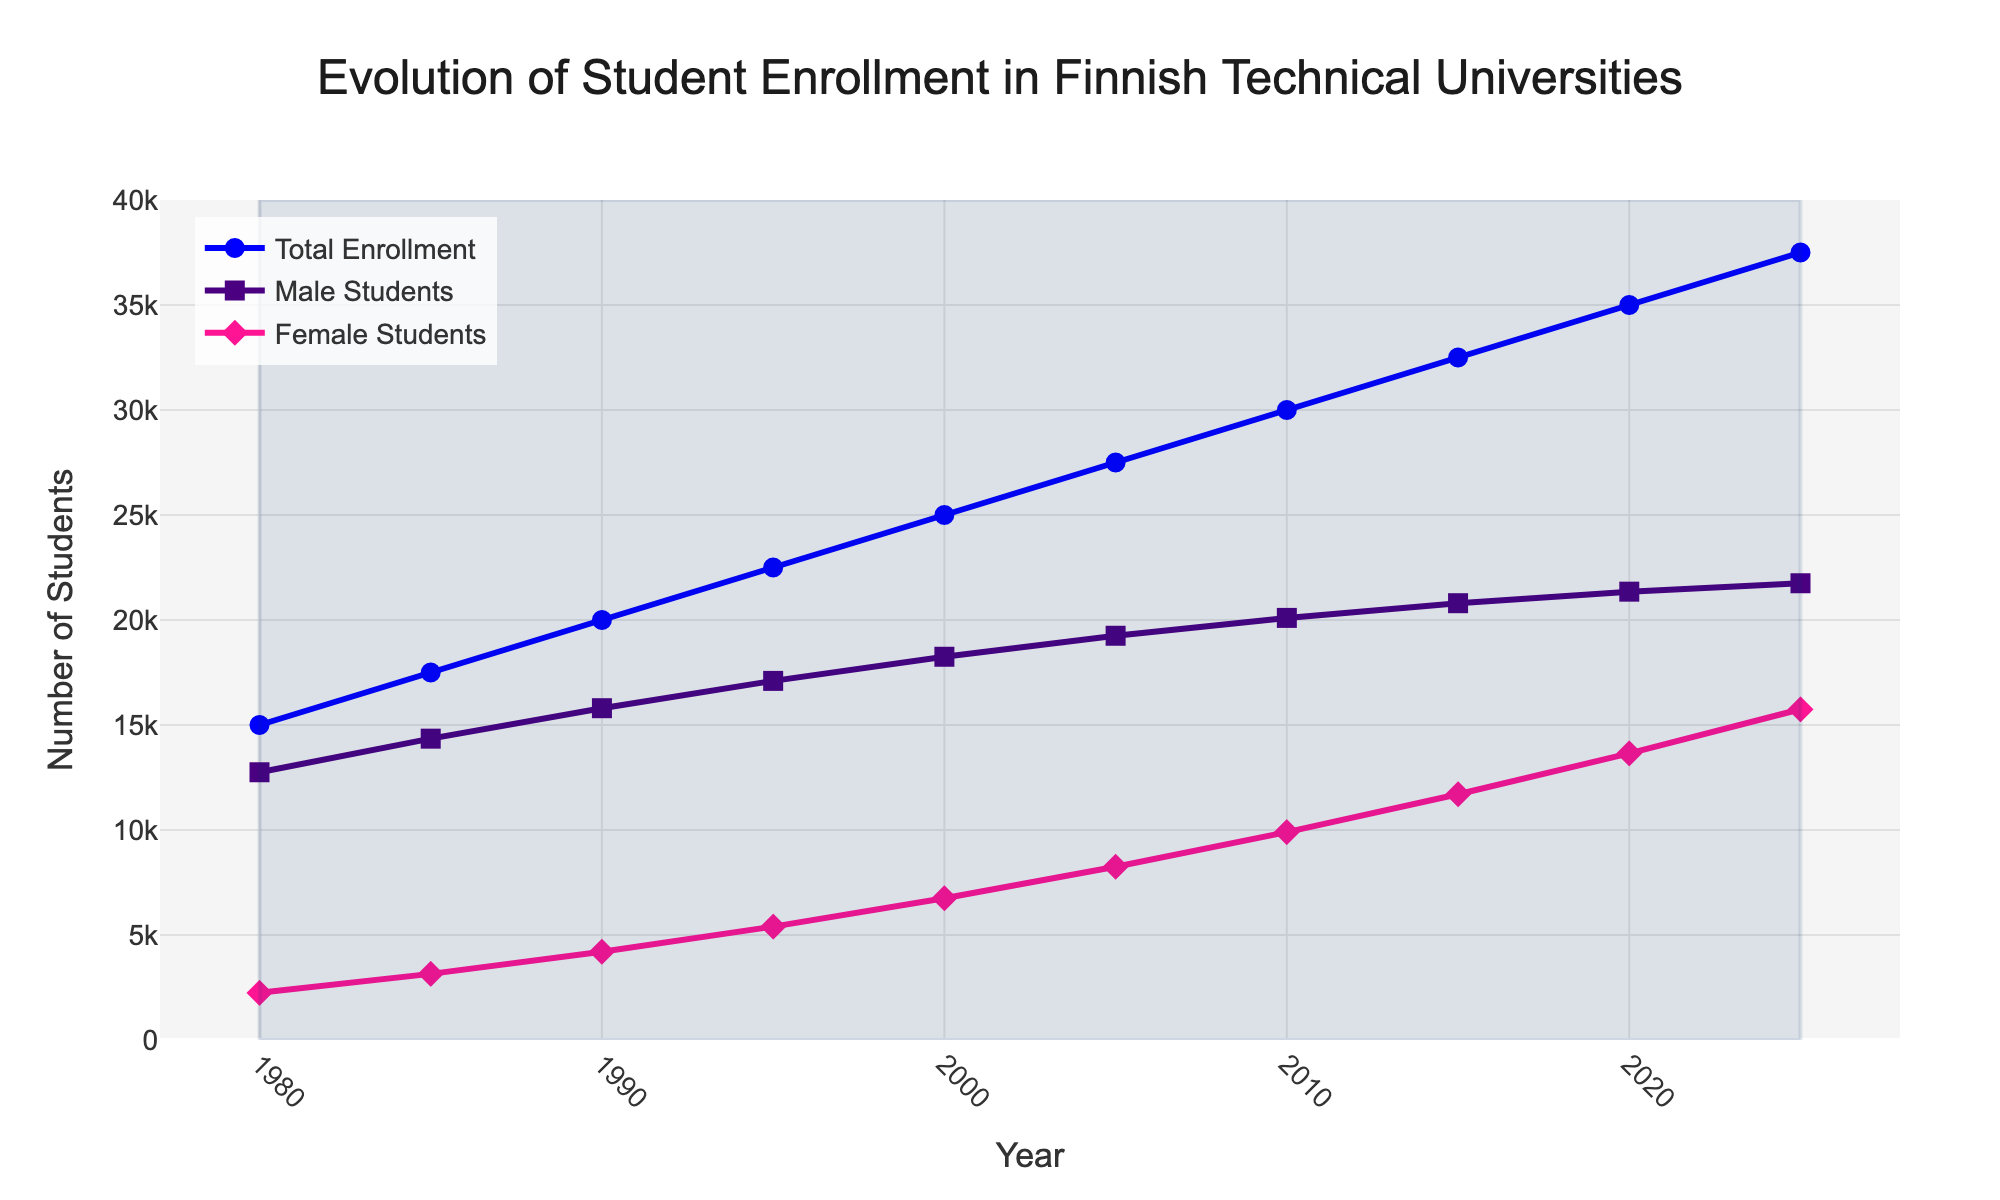What is the total student enrollment in 1990? Check the data point in the "Total Enrollment" line for the year 1990. The value is 20,000.
Answer: 20,000 What is the difference between the number of male and female students in 2005? From the graph, in 2005, male students are 19,250 and female students are 8,250. The difference is 19,250 - 8,250 = 11,000.
Answer: 11,000 By how much did the total enrollment increase from 1980 to 2020? In 1980, total enrollment is 15,000, while in 2020 it is 35,000. The increase is 35,000 - 15,000 = 20,000.
Answer: 20,000 Which year saw the highest enrollment among female students? Follow the "Female Students" line and identify the point with the highest value, which is in 2025 with 15,750 female students enrolled.
Answer: 2025 How much did the male student enrollment grow from 1980 to 2025? In 1980, male enrollment was 12,750, and in 2025 it is 21,750. The increment is 21,750 - 12,750 = 9,000.
Answer: 9,000 In which year did female students first exceed 10,000? Identify the first point on the "Female Students" line where the value exceeds 10,000, which occurs in 2010.
Answer: 2010 Compare the total enrollment between Aalto University and University of Oulu in 2005. Which one had more students? In 2005, Aalto University had 11,000 students while the University of Oulu had 6,000. Therefore, Aalto University had more students.
Answer: Aalto University What is the ratio of female to male students in 2020? In 2020, there are 21,350 male students and 13,650 female students. The ratio is 13,650 / 21,350, which simplifies approximately to 0.64.
Answer: 0.64 What is the average number of total enrollment between 1980 and 2000? Add total enrollments for 1980 (15,000), 1985 (17,500), 1990 (20,000), 1995 (22,500), and 2000 (25,000) and divide by 5. The total sum is 100,000 and the average is 100,000 / 5 = 20,000.
Answer: 20,000 